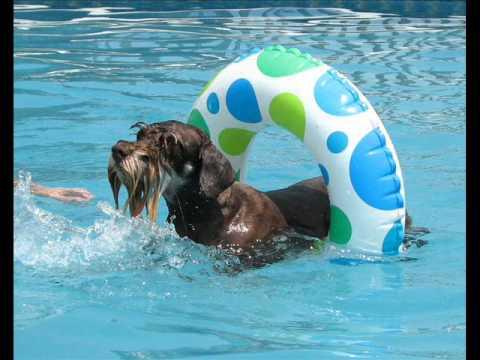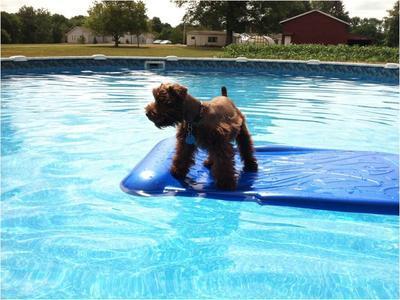The first image is the image on the left, the second image is the image on the right. Assess this claim about the two images: "An image shows a dog in a swim ring in a pool.". Correct or not? Answer yes or no. Yes. The first image is the image on the left, the second image is the image on the right. Given the left and right images, does the statement "At least one of the dogs is on a floatation device." hold true? Answer yes or no. Yes. 